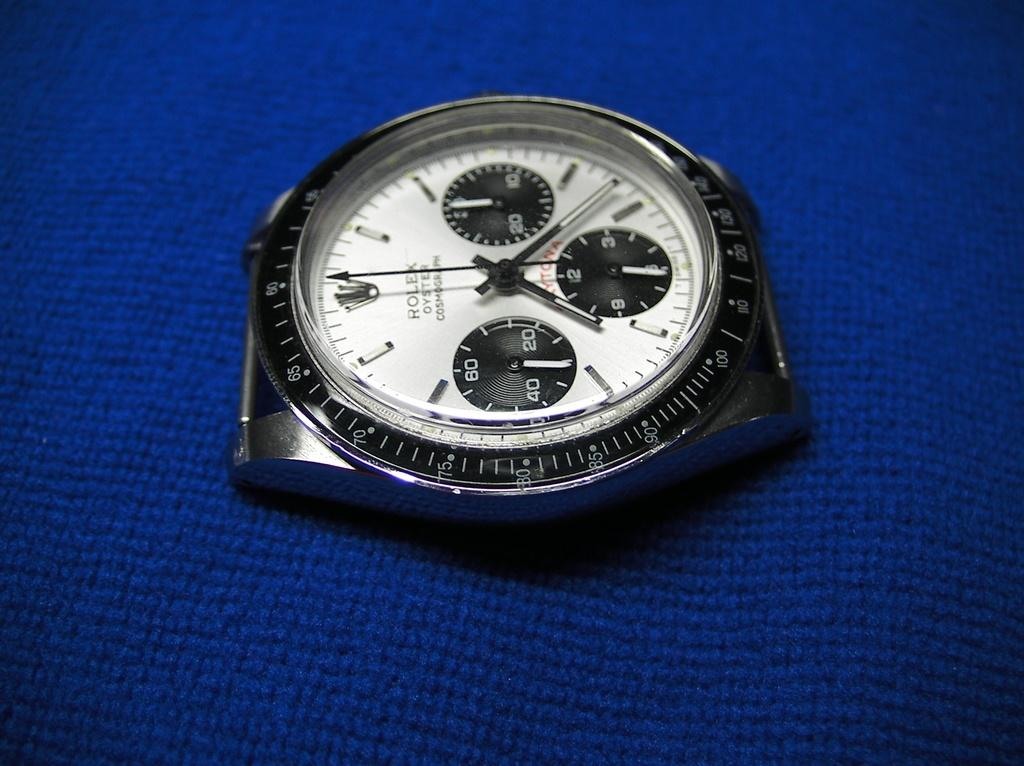<image>
Share a concise interpretation of the image provided. A strapless Rolex Oyster watch reads almost 7:20 as it lies on a blue cloth surface, 